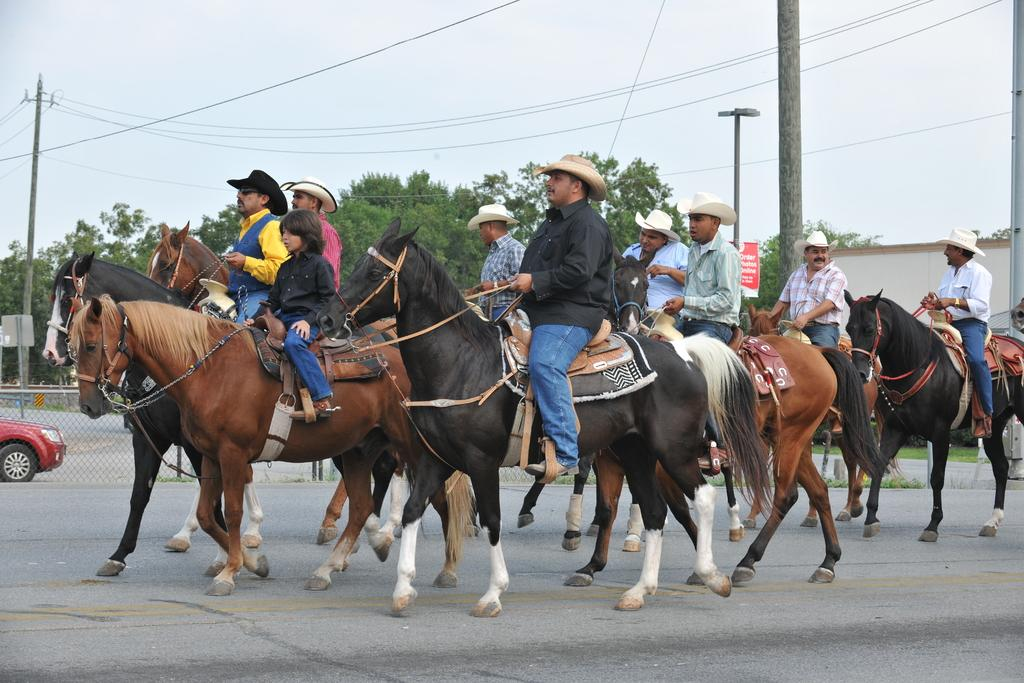What is happening in the image involving the group of people? The people are traveling on horses in the image. What can be seen in the image besides the group of people on horses? There are poles visible in the image. What is the background of the image like? There are many trees in the background of the image. What type of garden can be seen in the image? There is no garden present in the image; it features a group of people traveling on horses with poles and a background of many trees. 